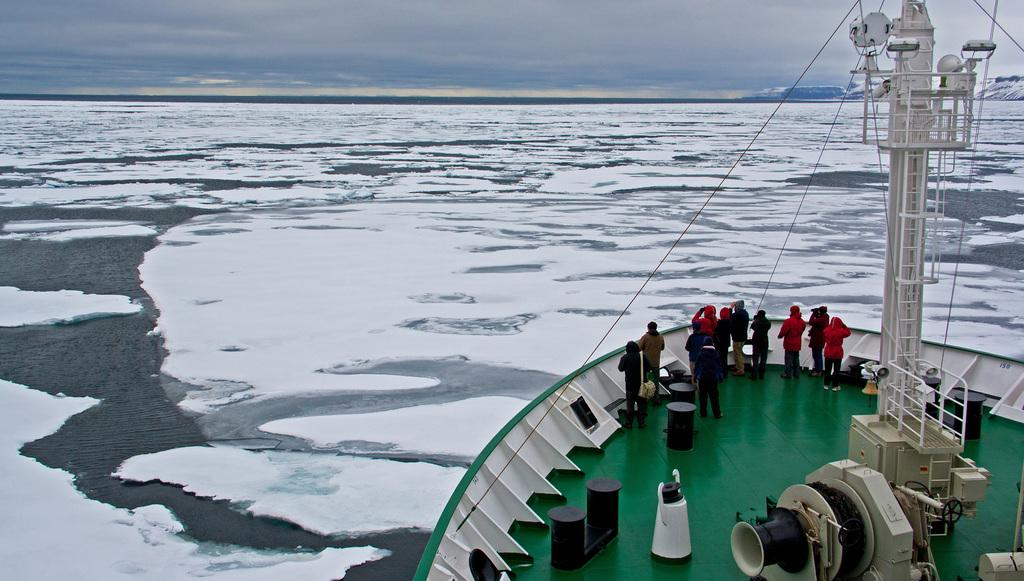What can be seen in the image? There are people and objects in the image. Can you describe the boat in the image? The boat is green and white in color. What is visible in the background of the image? The sky is visible in the image. What is the water condition in the image? There is water visible in the image, and it has ice on it. What news is being discussed by the people in the image? There is no indication of a news discussion in the image. 